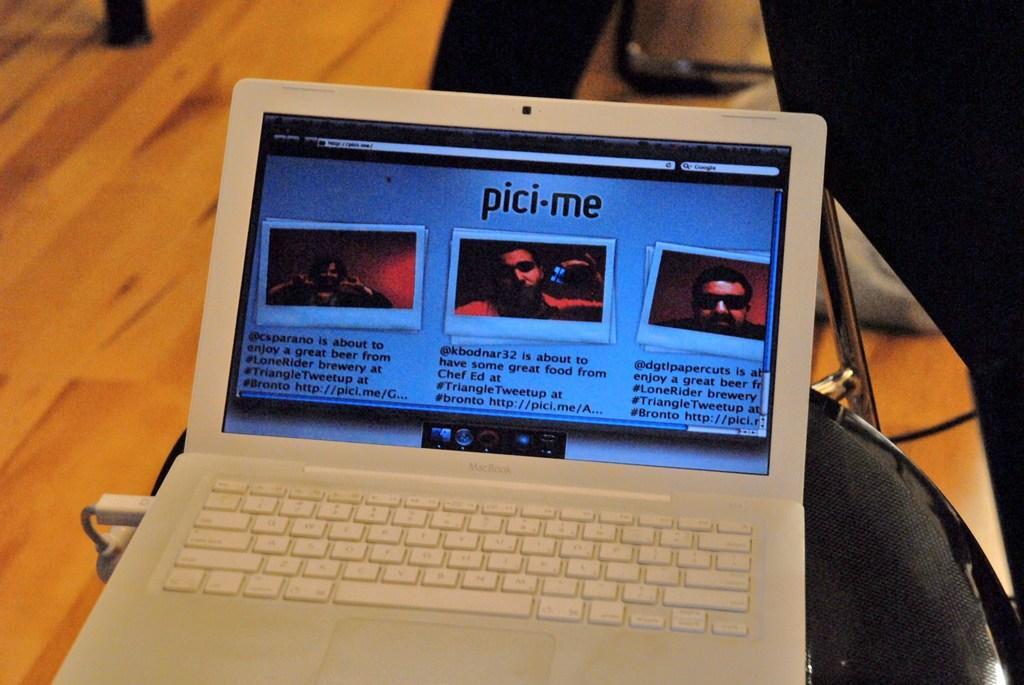In one or two sentences, can you explain what this image depicts? There is a laptop on the chair and this is floor. 